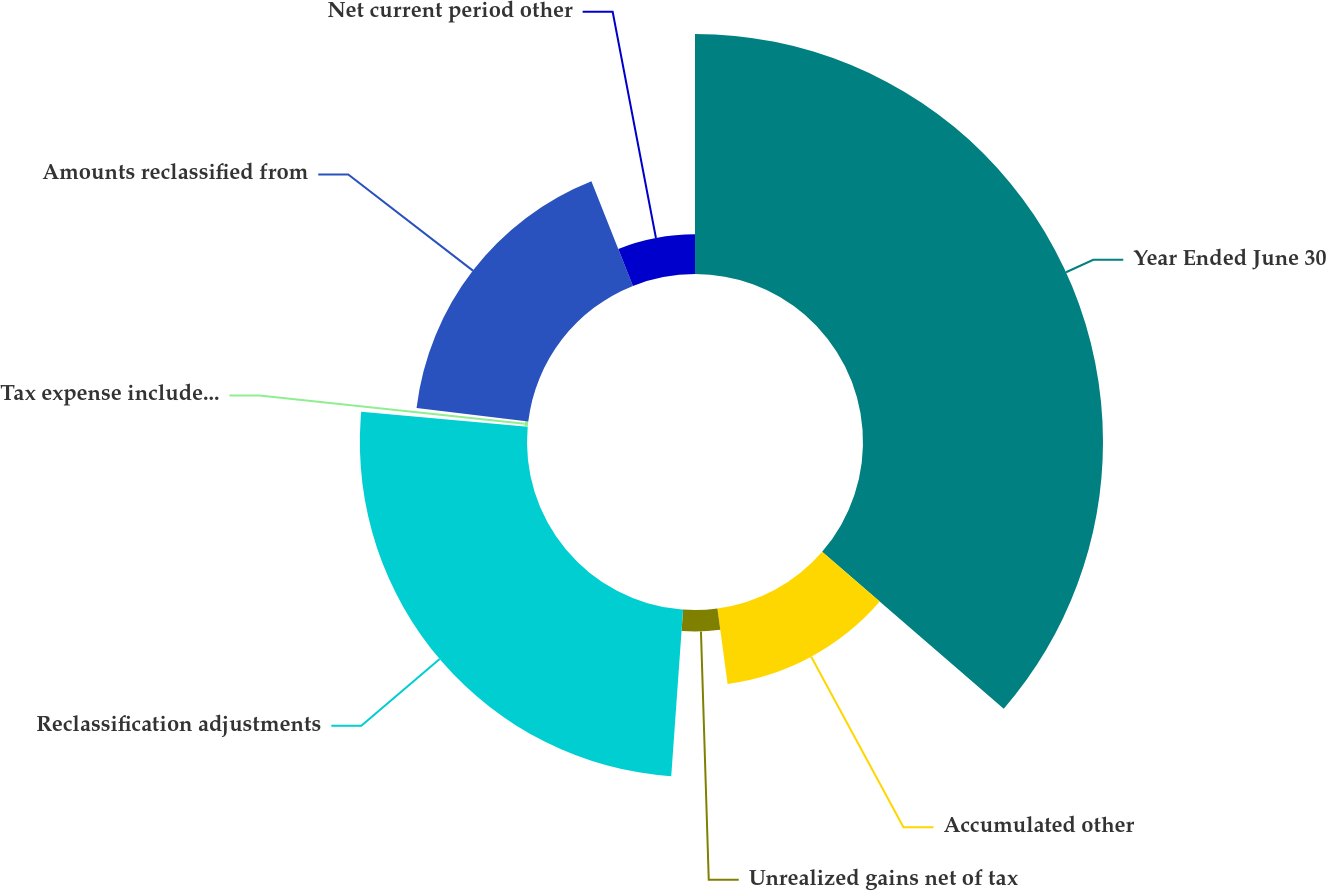Convert chart to OTSL. <chart><loc_0><loc_0><loc_500><loc_500><pie_chart><fcel>Year Ended June 30<fcel>Accumulated other<fcel>Unrealized gains net of tax<fcel>Reclassification adjustments<fcel>Tax expense included in<fcel>Amounts reclassified from<fcel>Net current period other<nl><fcel>36.34%<fcel>11.53%<fcel>3.26%<fcel>25.31%<fcel>0.5%<fcel>17.04%<fcel>6.02%<nl></chart> 